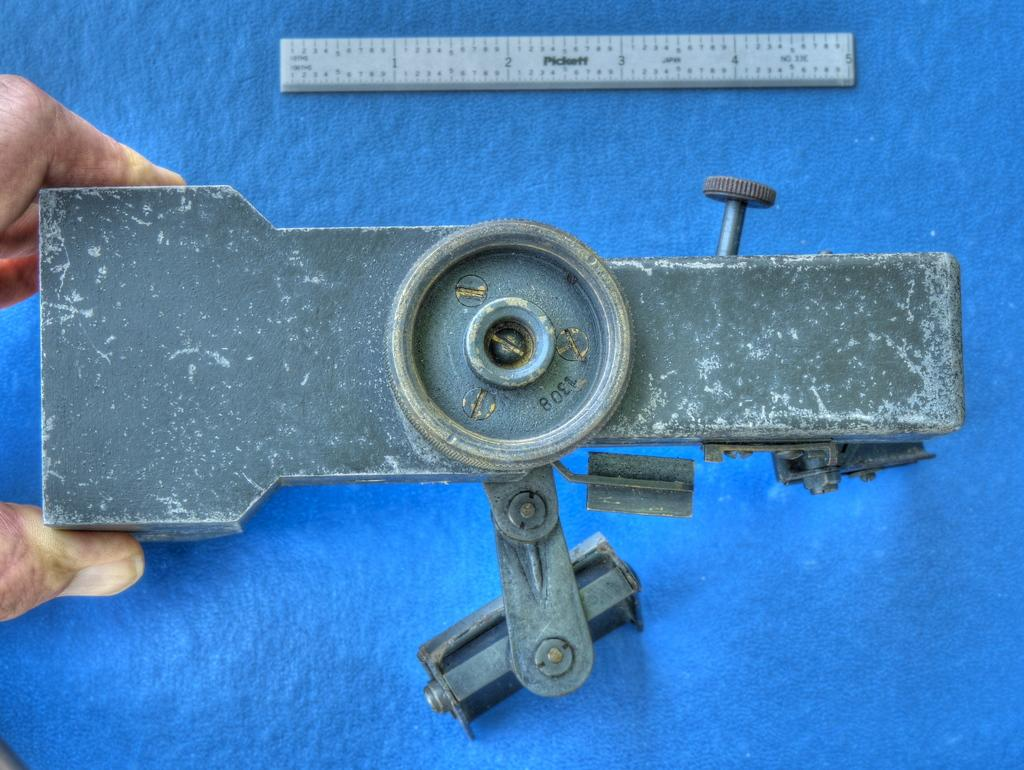<image>
Create a compact narrative representing the image presented. a small piece of metal that says 1308 on it 